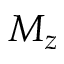<formula> <loc_0><loc_0><loc_500><loc_500>M _ { z }</formula> 